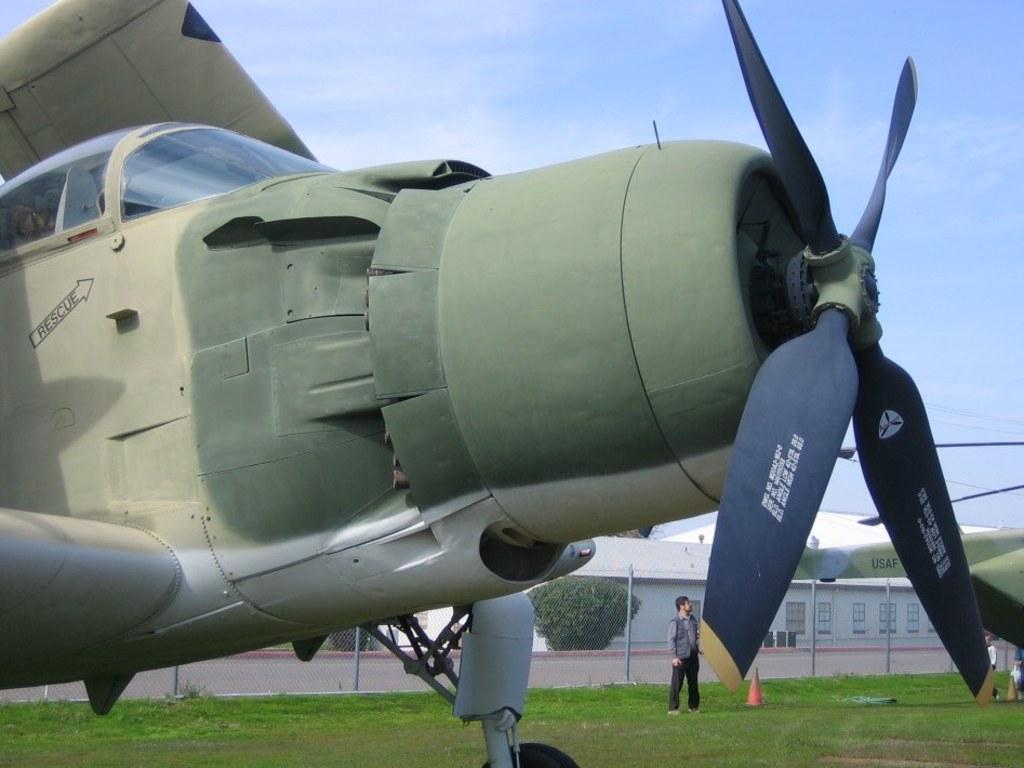What is written inside the arrow next to the cockpit?
Keep it short and to the point. Rescue. 